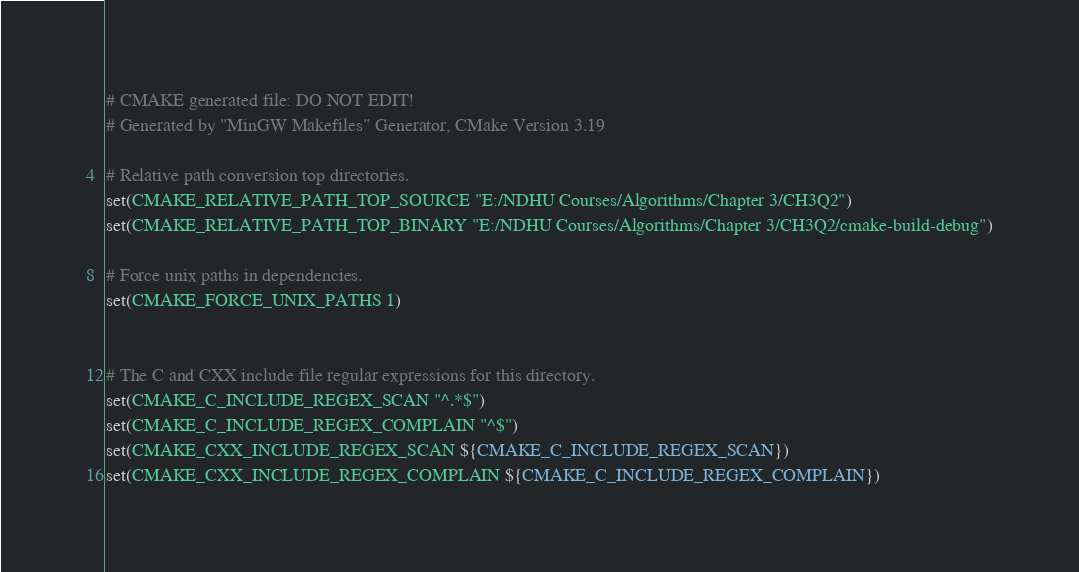Convert code to text. <code><loc_0><loc_0><loc_500><loc_500><_CMake_># CMAKE generated file: DO NOT EDIT!
# Generated by "MinGW Makefiles" Generator, CMake Version 3.19

# Relative path conversion top directories.
set(CMAKE_RELATIVE_PATH_TOP_SOURCE "E:/NDHU Courses/Algorithms/Chapter 3/CH3Q2")
set(CMAKE_RELATIVE_PATH_TOP_BINARY "E:/NDHU Courses/Algorithms/Chapter 3/CH3Q2/cmake-build-debug")

# Force unix paths in dependencies.
set(CMAKE_FORCE_UNIX_PATHS 1)


# The C and CXX include file regular expressions for this directory.
set(CMAKE_C_INCLUDE_REGEX_SCAN "^.*$")
set(CMAKE_C_INCLUDE_REGEX_COMPLAIN "^$")
set(CMAKE_CXX_INCLUDE_REGEX_SCAN ${CMAKE_C_INCLUDE_REGEX_SCAN})
set(CMAKE_CXX_INCLUDE_REGEX_COMPLAIN ${CMAKE_C_INCLUDE_REGEX_COMPLAIN})
</code> 